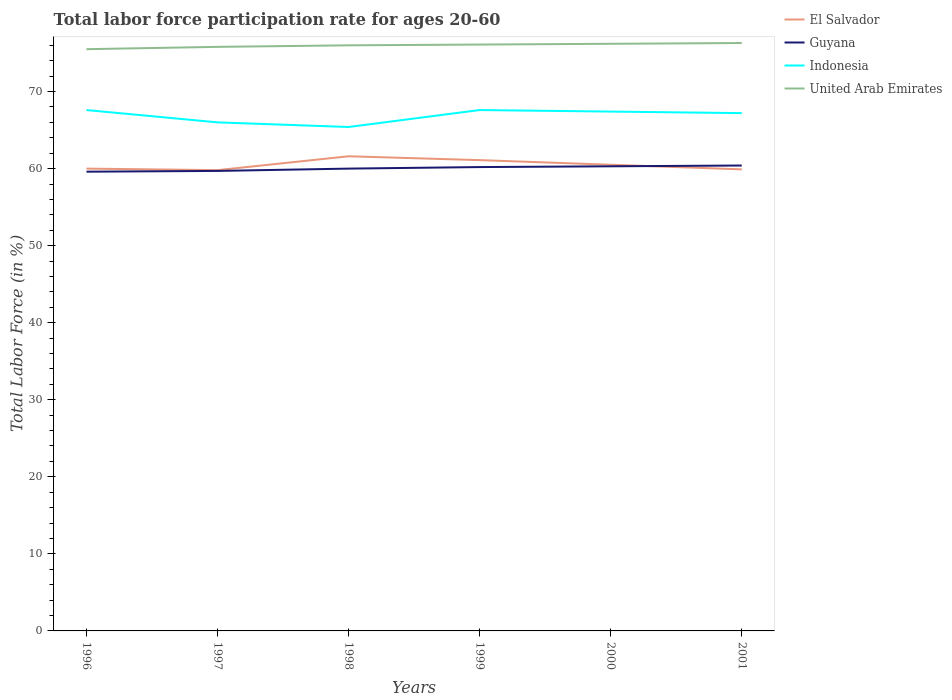How many different coloured lines are there?
Your answer should be compact. 4. Is the number of lines equal to the number of legend labels?
Keep it short and to the point. Yes. Across all years, what is the maximum labor force participation rate in Guyana?
Keep it short and to the point. 59.6. What is the total labor force participation rate in Indonesia in the graph?
Your answer should be very brief. 0.2. What is the difference between the highest and the second highest labor force participation rate in United Arab Emirates?
Provide a succinct answer. 0.8. What is the difference between the highest and the lowest labor force participation rate in El Salvador?
Offer a very short reply. 3. How many lines are there?
Make the answer very short. 4. Does the graph contain any zero values?
Make the answer very short. No. Does the graph contain grids?
Your response must be concise. No. How many legend labels are there?
Your response must be concise. 4. What is the title of the graph?
Offer a terse response. Total labor force participation rate for ages 20-60. What is the Total Labor Force (in %) in Guyana in 1996?
Provide a short and direct response. 59.6. What is the Total Labor Force (in %) of Indonesia in 1996?
Give a very brief answer. 67.6. What is the Total Labor Force (in %) in United Arab Emirates in 1996?
Make the answer very short. 75.5. What is the Total Labor Force (in %) of El Salvador in 1997?
Your response must be concise. 59.8. What is the Total Labor Force (in %) of Guyana in 1997?
Offer a very short reply. 59.7. What is the Total Labor Force (in %) in Indonesia in 1997?
Give a very brief answer. 66. What is the Total Labor Force (in %) in United Arab Emirates in 1997?
Offer a very short reply. 75.8. What is the Total Labor Force (in %) in El Salvador in 1998?
Ensure brevity in your answer.  61.6. What is the Total Labor Force (in %) of Indonesia in 1998?
Give a very brief answer. 65.4. What is the Total Labor Force (in %) in El Salvador in 1999?
Give a very brief answer. 61.1. What is the Total Labor Force (in %) in Guyana in 1999?
Give a very brief answer. 60.2. What is the Total Labor Force (in %) of Indonesia in 1999?
Keep it short and to the point. 67.6. What is the Total Labor Force (in %) in United Arab Emirates in 1999?
Offer a very short reply. 76.1. What is the Total Labor Force (in %) in El Salvador in 2000?
Your response must be concise. 60.5. What is the Total Labor Force (in %) of Guyana in 2000?
Ensure brevity in your answer.  60.3. What is the Total Labor Force (in %) in Indonesia in 2000?
Offer a terse response. 67.4. What is the Total Labor Force (in %) of United Arab Emirates in 2000?
Make the answer very short. 76.2. What is the Total Labor Force (in %) in El Salvador in 2001?
Keep it short and to the point. 59.9. What is the Total Labor Force (in %) in Guyana in 2001?
Your response must be concise. 60.4. What is the Total Labor Force (in %) of Indonesia in 2001?
Provide a short and direct response. 67.2. What is the Total Labor Force (in %) in United Arab Emirates in 2001?
Your response must be concise. 76.3. Across all years, what is the maximum Total Labor Force (in %) in El Salvador?
Provide a succinct answer. 61.6. Across all years, what is the maximum Total Labor Force (in %) of Guyana?
Offer a very short reply. 60.4. Across all years, what is the maximum Total Labor Force (in %) of Indonesia?
Your response must be concise. 67.6. Across all years, what is the maximum Total Labor Force (in %) in United Arab Emirates?
Offer a terse response. 76.3. Across all years, what is the minimum Total Labor Force (in %) of El Salvador?
Your response must be concise. 59.8. Across all years, what is the minimum Total Labor Force (in %) of Guyana?
Offer a terse response. 59.6. Across all years, what is the minimum Total Labor Force (in %) of Indonesia?
Your response must be concise. 65.4. Across all years, what is the minimum Total Labor Force (in %) in United Arab Emirates?
Your answer should be very brief. 75.5. What is the total Total Labor Force (in %) in El Salvador in the graph?
Provide a succinct answer. 362.9. What is the total Total Labor Force (in %) in Guyana in the graph?
Keep it short and to the point. 360.2. What is the total Total Labor Force (in %) of Indonesia in the graph?
Your response must be concise. 401.2. What is the total Total Labor Force (in %) of United Arab Emirates in the graph?
Keep it short and to the point. 455.9. What is the difference between the Total Labor Force (in %) in Indonesia in 1996 and that in 1997?
Make the answer very short. 1.6. What is the difference between the Total Labor Force (in %) in El Salvador in 1996 and that in 1998?
Your response must be concise. -1.6. What is the difference between the Total Labor Force (in %) of Guyana in 1996 and that in 1998?
Offer a very short reply. -0.4. What is the difference between the Total Labor Force (in %) of El Salvador in 1996 and that in 1999?
Provide a succinct answer. -1.1. What is the difference between the Total Labor Force (in %) in Guyana in 1996 and that in 1999?
Your answer should be very brief. -0.6. What is the difference between the Total Labor Force (in %) in Indonesia in 1996 and that in 1999?
Provide a succinct answer. 0. What is the difference between the Total Labor Force (in %) of United Arab Emirates in 1996 and that in 1999?
Your response must be concise. -0.6. What is the difference between the Total Labor Force (in %) of El Salvador in 1996 and that in 2000?
Offer a very short reply. -0.5. What is the difference between the Total Labor Force (in %) in Guyana in 1996 and that in 2001?
Offer a terse response. -0.8. What is the difference between the Total Labor Force (in %) in Indonesia in 1996 and that in 2001?
Your answer should be compact. 0.4. What is the difference between the Total Labor Force (in %) of United Arab Emirates in 1996 and that in 2001?
Your answer should be very brief. -0.8. What is the difference between the Total Labor Force (in %) of Guyana in 1997 and that in 1998?
Offer a very short reply. -0.3. What is the difference between the Total Labor Force (in %) in Guyana in 1997 and that in 1999?
Your response must be concise. -0.5. What is the difference between the Total Labor Force (in %) in United Arab Emirates in 1997 and that in 1999?
Your answer should be very brief. -0.3. What is the difference between the Total Labor Force (in %) in Guyana in 1997 and that in 2000?
Offer a very short reply. -0.6. What is the difference between the Total Labor Force (in %) in Indonesia in 1997 and that in 2000?
Offer a very short reply. -1.4. What is the difference between the Total Labor Force (in %) in United Arab Emirates in 1997 and that in 2000?
Provide a succinct answer. -0.4. What is the difference between the Total Labor Force (in %) in Indonesia in 1997 and that in 2001?
Offer a terse response. -1.2. What is the difference between the Total Labor Force (in %) in Indonesia in 1998 and that in 1999?
Offer a very short reply. -2.2. What is the difference between the Total Labor Force (in %) of United Arab Emirates in 1998 and that in 1999?
Ensure brevity in your answer.  -0.1. What is the difference between the Total Labor Force (in %) of Guyana in 1998 and that in 2000?
Offer a terse response. -0.3. What is the difference between the Total Labor Force (in %) in El Salvador in 1998 and that in 2001?
Make the answer very short. 1.7. What is the difference between the Total Labor Force (in %) of Guyana in 1998 and that in 2001?
Provide a succinct answer. -0.4. What is the difference between the Total Labor Force (in %) in Indonesia in 1998 and that in 2001?
Your response must be concise. -1.8. What is the difference between the Total Labor Force (in %) of United Arab Emirates in 1998 and that in 2001?
Provide a succinct answer. -0.3. What is the difference between the Total Labor Force (in %) in Guyana in 1999 and that in 2000?
Ensure brevity in your answer.  -0.1. What is the difference between the Total Labor Force (in %) in Indonesia in 1999 and that in 2000?
Your answer should be very brief. 0.2. What is the difference between the Total Labor Force (in %) of United Arab Emirates in 1999 and that in 2000?
Provide a succinct answer. -0.1. What is the difference between the Total Labor Force (in %) in Indonesia in 1999 and that in 2001?
Your answer should be compact. 0.4. What is the difference between the Total Labor Force (in %) of Indonesia in 2000 and that in 2001?
Keep it short and to the point. 0.2. What is the difference between the Total Labor Force (in %) of United Arab Emirates in 2000 and that in 2001?
Offer a terse response. -0.1. What is the difference between the Total Labor Force (in %) in El Salvador in 1996 and the Total Labor Force (in %) in Guyana in 1997?
Ensure brevity in your answer.  0.3. What is the difference between the Total Labor Force (in %) of El Salvador in 1996 and the Total Labor Force (in %) of Indonesia in 1997?
Offer a terse response. -6. What is the difference between the Total Labor Force (in %) of El Salvador in 1996 and the Total Labor Force (in %) of United Arab Emirates in 1997?
Make the answer very short. -15.8. What is the difference between the Total Labor Force (in %) in Guyana in 1996 and the Total Labor Force (in %) in United Arab Emirates in 1997?
Provide a succinct answer. -16.2. What is the difference between the Total Labor Force (in %) of El Salvador in 1996 and the Total Labor Force (in %) of Guyana in 1998?
Your answer should be compact. 0. What is the difference between the Total Labor Force (in %) in El Salvador in 1996 and the Total Labor Force (in %) in Indonesia in 1998?
Offer a very short reply. -5.4. What is the difference between the Total Labor Force (in %) in El Salvador in 1996 and the Total Labor Force (in %) in United Arab Emirates in 1998?
Offer a terse response. -16. What is the difference between the Total Labor Force (in %) in Guyana in 1996 and the Total Labor Force (in %) in Indonesia in 1998?
Your answer should be compact. -5.8. What is the difference between the Total Labor Force (in %) in Guyana in 1996 and the Total Labor Force (in %) in United Arab Emirates in 1998?
Your response must be concise. -16.4. What is the difference between the Total Labor Force (in %) of El Salvador in 1996 and the Total Labor Force (in %) of Guyana in 1999?
Make the answer very short. -0.2. What is the difference between the Total Labor Force (in %) of El Salvador in 1996 and the Total Labor Force (in %) of Indonesia in 1999?
Your answer should be compact. -7.6. What is the difference between the Total Labor Force (in %) in El Salvador in 1996 and the Total Labor Force (in %) in United Arab Emirates in 1999?
Offer a terse response. -16.1. What is the difference between the Total Labor Force (in %) in Guyana in 1996 and the Total Labor Force (in %) in United Arab Emirates in 1999?
Make the answer very short. -16.5. What is the difference between the Total Labor Force (in %) in Indonesia in 1996 and the Total Labor Force (in %) in United Arab Emirates in 1999?
Give a very brief answer. -8.5. What is the difference between the Total Labor Force (in %) in El Salvador in 1996 and the Total Labor Force (in %) in Guyana in 2000?
Give a very brief answer. -0.3. What is the difference between the Total Labor Force (in %) in El Salvador in 1996 and the Total Labor Force (in %) in United Arab Emirates in 2000?
Your response must be concise. -16.2. What is the difference between the Total Labor Force (in %) of Guyana in 1996 and the Total Labor Force (in %) of United Arab Emirates in 2000?
Give a very brief answer. -16.6. What is the difference between the Total Labor Force (in %) in Indonesia in 1996 and the Total Labor Force (in %) in United Arab Emirates in 2000?
Keep it short and to the point. -8.6. What is the difference between the Total Labor Force (in %) in El Salvador in 1996 and the Total Labor Force (in %) in Indonesia in 2001?
Offer a terse response. -7.2. What is the difference between the Total Labor Force (in %) of El Salvador in 1996 and the Total Labor Force (in %) of United Arab Emirates in 2001?
Provide a short and direct response. -16.3. What is the difference between the Total Labor Force (in %) in Guyana in 1996 and the Total Labor Force (in %) in United Arab Emirates in 2001?
Make the answer very short. -16.7. What is the difference between the Total Labor Force (in %) in Indonesia in 1996 and the Total Labor Force (in %) in United Arab Emirates in 2001?
Ensure brevity in your answer.  -8.7. What is the difference between the Total Labor Force (in %) of El Salvador in 1997 and the Total Labor Force (in %) of Guyana in 1998?
Your answer should be very brief. -0.2. What is the difference between the Total Labor Force (in %) of El Salvador in 1997 and the Total Labor Force (in %) of United Arab Emirates in 1998?
Keep it short and to the point. -16.2. What is the difference between the Total Labor Force (in %) of Guyana in 1997 and the Total Labor Force (in %) of United Arab Emirates in 1998?
Keep it short and to the point. -16.3. What is the difference between the Total Labor Force (in %) of El Salvador in 1997 and the Total Labor Force (in %) of Indonesia in 1999?
Ensure brevity in your answer.  -7.8. What is the difference between the Total Labor Force (in %) in El Salvador in 1997 and the Total Labor Force (in %) in United Arab Emirates in 1999?
Offer a terse response. -16.3. What is the difference between the Total Labor Force (in %) in Guyana in 1997 and the Total Labor Force (in %) in Indonesia in 1999?
Ensure brevity in your answer.  -7.9. What is the difference between the Total Labor Force (in %) in Guyana in 1997 and the Total Labor Force (in %) in United Arab Emirates in 1999?
Offer a terse response. -16.4. What is the difference between the Total Labor Force (in %) in Indonesia in 1997 and the Total Labor Force (in %) in United Arab Emirates in 1999?
Make the answer very short. -10.1. What is the difference between the Total Labor Force (in %) of El Salvador in 1997 and the Total Labor Force (in %) of Indonesia in 2000?
Offer a very short reply. -7.6. What is the difference between the Total Labor Force (in %) in El Salvador in 1997 and the Total Labor Force (in %) in United Arab Emirates in 2000?
Offer a terse response. -16.4. What is the difference between the Total Labor Force (in %) of Guyana in 1997 and the Total Labor Force (in %) of Indonesia in 2000?
Your answer should be compact. -7.7. What is the difference between the Total Labor Force (in %) of Guyana in 1997 and the Total Labor Force (in %) of United Arab Emirates in 2000?
Offer a very short reply. -16.5. What is the difference between the Total Labor Force (in %) in Indonesia in 1997 and the Total Labor Force (in %) in United Arab Emirates in 2000?
Your answer should be very brief. -10.2. What is the difference between the Total Labor Force (in %) in El Salvador in 1997 and the Total Labor Force (in %) in Guyana in 2001?
Make the answer very short. -0.6. What is the difference between the Total Labor Force (in %) in El Salvador in 1997 and the Total Labor Force (in %) in United Arab Emirates in 2001?
Offer a very short reply. -16.5. What is the difference between the Total Labor Force (in %) of Guyana in 1997 and the Total Labor Force (in %) of United Arab Emirates in 2001?
Make the answer very short. -16.6. What is the difference between the Total Labor Force (in %) in El Salvador in 1998 and the Total Labor Force (in %) in Guyana in 1999?
Offer a terse response. 1.4. What is the difference between the Total Labor Force (in %) in El Salvador in 1998 and the Total Labor Force (in %) in Indonesia in 1999?
Give a very brief answer. -6. What is the difference between the Total Labor Force (in %) in Guyana in 1998 and the Total Labor Force (in %) in United Arab Emirates in 1999?
Your answer should be compact. -16.1. What is the difference between the Total Labor Force (in %) in Indonesia in 1998 and the Total Labor Force (in %) in United Arab Emirates in 1999?
Provide a short and direct response. -10.7. What is the difference between the Total Labor Force (in %) of El Salvador in 1998 and the Total Labor Force (in %) of Guyana in 2000?
Offer a very short reply. 1.3. What is the difference between the Total Labor Force (in %) in El Salvador in 1998 and the Total Labor Force (in %) in United Arab Emirates in 2000?
Your response must be concise. -14.6. What is the difference between the Total Labor Force (in %) of Guyana in 1998 and the Total Labor Force (in %) of Indonesia in 2000?
Offer a very short reply. -7.4. What is the difference between the Total Labor Force (in %) of Guyana in 1998 and the Total Labor Force (in %) of United Arab Emirates in 2000?
Provide a succinct answer. -16.2. What is the difference between the Total Labor Force (in %) in Indonesia in 1998 and the Total Labor Force (in %) in United Arab Emirates in 2000?
Offer a terse response. -10.8. What is the difference between the Total Labor Force (in %) of El Salvador in 1998 and the Total Labor Force (in %) of Indonesia in 2001?
Offer a terse response. -5.6. What is the difference between the Total Labor Force (in %) of El Salvador in 1998 and the Total Labor Force (in %) of United Arab Emirates in 2001?
Offer a terse response. -14.7. What is the difference between the Total Labor Force (in %) of Guyana in 1998 and the Total Labor Force (in %) of Indonesia in 2001?
Provide a short and direct response. -7.2. What is the difference between the Total Labor Force (in %) in Guyana in 1998 and the Total Labor Force (in %) in United Arab Emirates in 2001?
Give a very brief answer. -16.3. What is the difference between the Total Labor Force (in %) in Indonesia in 1998 and the Total Labor Force (in %) in United Arab Emirates in 2001?
Give a very brief answer. -10.9. What is the difference between the Total Labor Force (in %) in El Salvador in 1999 and the Total Labor Force (in %) in Guyana in 2000?
Ensure brevity in your answer.  0.8. What is the difference between the Total Labor Force (in %) in El Salvador in 1999 and the Total Labor Force (in %) in United Arab Emirates in 2000?
Provide a succinct answer. -15.1. What is the difference between the Total Labor Force (in %) of Guyana in 1999 and the Total Labor Force (in %) of Indonesia in 2000?
Keep it short and to the point. -7.2. What is the difference between the Total Labor Force (in %) of Indonesia in 1999 and the Total Labor Force (in %) of United Arab Emirates in 2000?
Give a very brief answer. -8.6. What is the difference between the Total Labor Force (in %) in El Salvador in 1999 and the Total Labor Force (in %) in Guyana in 2001?
Keep it short and to the point. 0.7. What is the difference between the Total Labor Force (in %) in El Salvador in 1999 and the Total Labor Force (in %) in Indonesia in 2001?
Your answer should be compact. -6.1. What is the difference between the Total Labor Force (in %) in El Salvador in 1999 and the Total Labor Force (in %) in United Arab Emirates in 2001?
Give a very brief answer. -15.2. What is the difference between the Total Labor Force (in %) in Guyana in 1999 and the Total Labor Force (in %) in Indonesia in 2001?
Make the answer very short. -7. What is the difference between the Total Labor Force (in %) in Guyana in 1999 and the Total Labor Force (in %) in United Arab Emirates in 2001?
Provide a short and direct response. -16.1. What is the difference between the Total Labor Force (in %) of El Salvador in 2000 and the Total Labor Force (in %) of Guyana in 2001?
Keep it short and to the point. 0.1. What is the difference between the Total Labor Force (in %) of El Salvador in 2000 and the Total Labor Force (in %) of Indonesia in 2001?
Make the answer very short. -6.7. What is the difference between the Total Labor Force (in %) in El Salvador in 2000 and the Total Labor Force (in %) in United Arab Emirates in 2001?
Offer a terse response. -15.8. What is the difference between the Total Labor Force (in %) of Guyana in 2000 and the Total Labor Force (in %) of United Arab Emirates in 2001?
Make the answer very short. -16. What is the average Total Labor Force (in %) in El Salvador per year?
Give a very brief answer. 60.48. What is the average Total Labor Force (in %) in Guyana per year?
Your response must be concise. 60.03. What is the average Total Labor Force (in %) in Indonesia per year?
Your response must be concise. 66.87. What is the average Total Labor Force (in %) of United Arab Emirates per year?
Your response must be concise. 75.98. In the year 1996, what is the difference between the Total Labor Force (in %) of El Salvador and Total Labor Force (in %) of Guyana?
Your answer should be very brief. 0.4. In the year 1996, what is the difference between the Total Labor Force (in %) of El Salvador and Total Labor Force (in %) of United Arab Emirates?
Give a very brief answer. -15.5. In the year 1996, what is the difference between the Total Labor Force (in %) in Guyana and Total Labor Force (in %) in Indonesia?
Provide a succinct answer. -8. In the year 1996, what is the difference between the Total Labor Force (in %) of Guyana and Total Labor Force (in %) of United Arab Emirates?
Provide a short and direct response. -15.9. In the year 1996, what is the difference between the Total Labor Force (in %) in Indonesia and Total Labor Force (in %) in United Arab Emirates?
Provide a short and direct response. -7.9. In the year 1997, what is the difference between the Total Labor Force (in %) in El Salvador and Total Labor Force (in %) in Indonesia?
Your answer should be compact. -6.2. In the year 1997, what is the difference between the Total Labor Force (in %) of El Salvador and Total Labor Force (in %) of United Arab Emirates?
Give a very brief answer. -16. In the year 1997, what is the difference between the Total Labor Force (in %) in Guyana and Total Labor Force (in %) in United Arab Emirates?
Your response must be concise. -16.1. In the year 1998, what is the difference between the Total Labor Force (in %) in El Salvador and Total Labor Force (in %) in Indonesia?
Ensure brevity in your answer.  -3.8. In the year 1998, what is the difference between the Total Labor Force (in %) of El Salvador and Total Labor Force (in %) of United Arab Emirates?
Ensure brevity in your answer.  -14.4. In the year 1998, what is the difference between the Total Labor Force (in %) in Guyana and Total Labor Force (in %) in Indonesia?
Keep it short and to the point. -5.4. In the year 1998, what is the difference between the Total Labor Force (in %) in Guyana and Total Labor Force (in %) in United Arab Emirates?
Your response must be concise. -16. In the year 1999, what is the difference between the Total Labor Force (in %) in El Salvador and Total Labor Force (in %) in Guyana?
Provide a succinct answer. 0.9. In the year 1999, what is the difference between the Total Labor Force (in %) in El Salvador and Total Labor Force (in %) in Indonesia?
Give a very brief answer. -6.5. In the year 1999, what is the difference between the Total Labor Force (in %) in Guyana and Total Labor Force (in %) in Indonesia?
Your answer should be very brief. -7.4. In the year 1999, what is the difference between the Total Labor Force (in %) in Guyana and Total Labor Force (in %) in United Arab Emirates?
Give a very brief answer. -15.9. In the year 2000, what is the difference between the Total Labor Force (in %) in El Salvador and Total Labor Force (in %) in Guyana?
Your response must be concise. 0.2. In the year 2000, what is the difference between the Total Labor Force (in %) in El Salvador and Total Labor Force (in %) in Indonesia?
Provide a succinct answer. -6.9. In the year 2000, what is the difference between the Total Labor Force (in %) in El Salvador and Total Labor Force (in %) in United Arab Emirates?
Provide a succinct answer. -15.7. In the year 2000, what is the difference between the Total Labor Force (in %) in Guyana and Total Labor Force (in %) in Indonesia?
Provide a succinct answer. -7.1. In the year 2000, what is the difference between the Total Labor Force (in %) in Guyana and Total Labor Force (in %) in United Arab Emirates?
Your answer should be very brief. -15.9. In the year 2000, what is the difference between the Total Labor Force (in %) of Indonesia and Total Labor Force (in %) of United Arab Emirates?
Make the answer very short. -8.8. In the year 2001, what is the difference between the Total Labor Force (in %) of El Salvador and Total Labor Force (in %) of Guyana?
Provide a succinct answer. -0.5. In the year 2001, what is the difference between the Total Labor Force (in %) of El Salvador and Total Labor Force (in %) of Indonesia?
Provide a succinct answer. -7.3. In the year 2001, what is the difference between the Total Labor Force (in %) in El Salvador and Total Labor Force (in %) in United Arab Emirates?
Offer a terse response. -16.4. In the year 2001, what is the difference between the Total Labor Force (in %) of Guyana and Total Labor Force (in %) of United Arab Emirates?
Your response must be concise. -15.9. In the year 2001, what is the difference between the Total Labor Force (in %) in Indonesia and Total Labor Force (in %) in United Arab Emirates?
Offer a terse response. -9.1. What is the ratio of the Total Labor Force (in %) in El Salvador in 1996 to that in 1997?
Keep it short and to the point. 1. What is the ratio of the Total Labor Force (in %) in Guyana in 1996 to that in 1997?
Ensure brevity in your answer.  1. What is the ratio of the Total Labor Force (in %) in Indonesia in 1996 to that in 1997?
Your answer should be compact. 1.02. What is the ratio of the Total Labor Force (in %) in El Salvador in 1996 to that in 1998?
Offer a terse response. 0.97. What is the ratio of the Total Labor Force (in %) of Indonesia in 1996 to that in 1998?
Provide a succinct answer. 1.03. What is the ratio of the Total Labor Force (in %) of United Arab Emirates in 1996 to that in 1998?
Provide a short and direct response. 0.99. What is the ratio of the Total Labor Force (in %) in El Salvador in 1996 to that in 1999?
Give a very brief answer. 0.98. What is the ratio of the Total Labor Force (in %) of El Salvador in 1996 to that in 2000?
Offer a very short reply. 0.99. What is the ratio of the Total Labor Force (in %) of Guyana in 1996 to that in 2000?
Ensure brevity in your answer.  0.99. What is the ratio of the Total Labor Force (in %) of Indonesia in 1996 to that in 2000?
Your answer should be very brief. 1. What is the ratio of the Total Labor Force (in %) of Guyana in 1996 to that in 2001?
Your response must be concise. 0.99. What is the ratio of the Total Labor Force (in %) in United Arab Emirates in 1996 to that in 2001?
Keep it short and to the point. 0.99. What is the ratio of the Total Labor Force (in %) of El Salvador in 1997 to that in 1998?
Make the answer very short. 0.97. What is the ratio of the Total Labor Force (in %) in Guyana in 1997 to that in 1998?
Provide a succinct answer. 0.99. What is the ratio of the Total Labor Force (in %) of Indonesia in 1997 to that in 1998?
Your answer should be compact. 1.01. What is the ratio of the Total Labor Force (in %) of El Salvador in 1997 to that in 1999?
Offer a terse response. 0.98. What is the ratio of the Total Labor Force (in %) of Indonesia in 1997 to that in 1999?
Provide a short and direct response. 0.98. What is the ratio of the Total Labor Force (in %) in United Arab Emirates in 1997 to that in 1999?
Your response must be concise. 1. What is the ratio of the Total Labor Force (in %) in El Salvador in 1997 to that in 2000?
Your answer should be compact. 0.99. What is the ratio of the Total Labor Force (in %) of Guyana in 1997 to that in 2000?
Ensure brevity in your answer.  0.99. What is the ratio of the Total Labor Force (in %) in Indonesia in 1997 to that in 2000?
Offer a very short reply. 0.98. What is the ratio of the Total Labor Force (in %) of United Arab Emirates in 1997 to that in 2000?
Provide a short and direct response. 0.99. What is the ratio of the Total Labor Force (in %) in Guyana in 1997 to that in 2001?
Offer a very short reply. 0.99. What is the ratio of the Total Labor Force (in %) in Indonesia in 1997 to that in 2001?
Your answer should be compact. 0.98. What is the ratio of the Total Labor Force (in %) of United Arab Emirates in 1997 to that in 2001?
Your answer should be compact. 0.99. What is the ratio of the Total Labor Force (in %) of El Salvador in 1998 to that in 1999?
Make the answer very short. 1.01. What is the ratio of the Total Labor Force (in %) of Indonesia in 1998 to that in 1999?
Your answer should be very brief. 0.97. What is the ratio of the Total Labor Force (in %) in United Arab Emirates in 1998 to that in 1999?
Provide a short and direct response. 1. What is the ratio of the Total Labor Force (in %) of El Salvador in 1998 to that in 2000?
Your answer should be compact. 1.02. What is the ratio of the Total Labor Force (in %) of Guyana in 1998 to that in 2000?
Provide a succinct answer. 0.99. What is the ratio of the Total Labor Force (in %) of Indonesia in 1998 to that in 2000?
Keep it short and to the point. 0.97. What is the ratio of the Total Labor Force (in %) of United Arab Emirates in 1998 to that in 2000?
Provide a succinct answer. 1. What is the ratio of the Total Labor Force (in %) of El Salvador in 1998 to that in 2001?
Offer a very short reply. 1.03. What is the ratio of the Total Labor Force (in %) in Indonesia in 1998 to that in 2001?
Give a very brief answer. 0.97. What is the ratio of the Total Labor Force (in %) in United Arab Emirates in 1998 to that in 2001?
Your answer should be compact. 1. What is the ratio of the Total Labor Force (in %) of El Salvador in 1999 to that in 2000?
Give a very brief answer. 1.01. What is the ratio of the Total Labor Force (in %) in Guyana in 1999 to that in 2000?
Ensure brevity in your answer.  1. What is the ratio of the Total Labor Force (in %) in Indonesia in 1999 to that in 2000?
Give a very brief answer. 1. What is the ratio of the Total Labor Force (in %) in United Arab Emirates in 1999 to that in 2000?
Offer a very short reply. 1. What is the ratio of the Total Labor Force (in %) of El Salvador in 1999 to that in 2001?
Offer a very short reply. 1.02. What is the ratio of the Total Labor Force (in %) of Guyana in 1999 to that in 2001?
Provide a succinct answer. 1. What is the ratio of the Total Labor Force (in %) in Guyana in 2000 to that in 2001?
Your response must be concise. 1. What is the ratio of the Total Labor Force (in %) of Indonesia in 2000 to that in 2001?
Give a very brief answer. 1. What is the difference between the highest and the second highest Total Labor Force (in %) in United Arab Emirates?
Your answer should be compact. 0.1. What is the difference between the highest and the lowest Total Labor Force (in %) in Guyana?
Make the answer very short. 0.8. What is the difference between the highest and the lowest Total Labor Force (in %) of Indonesia?
Offer a very short reply. 2.2. 